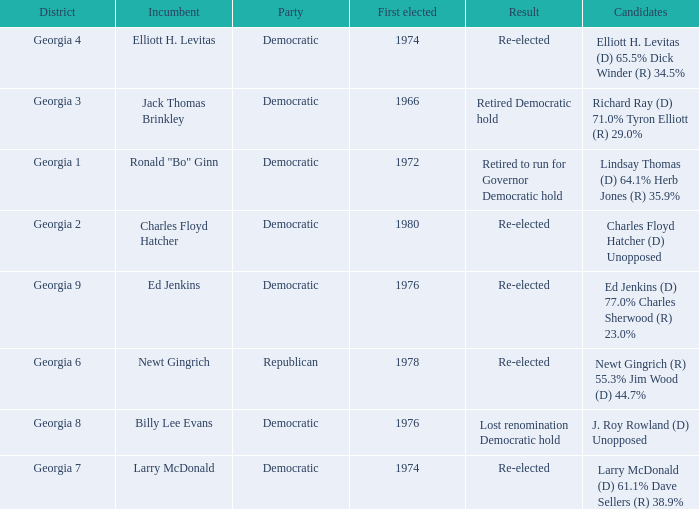Name the districk for larry mcdonald Georgia 7. Could you help me parse every detail presented in this table? {'header': ['District', 'Incumbent', 'Party', 'First elected', 'Result', 'Candidates'], 'rows': [['Georgia 4', 'Elliott H. Levitas', 'Democratic', '1974', 'Re-elected', 'Elliott H. Levitas (D) 65.5% Dick Winder (R) 34.5%'], ['Georgia 3', 'Jack Thomas Brinkley', 'Democratic', '1966', 'Retired Democratic hold', 'Richard Ray (D) 71.0% Tyron Elliott (R) 29.0%'], ['Georgia 1', 'Ronald "Bo" Ginn', 'Democratic', '1972', 'Retired to run for Governor Democratic hold', 'Lindsay Thomas (D) 64.1% Herb Jones (R) 35.9%'], ['Georgia 2', 'Charles Floyd Hatcher', 'Democratic', '1980', 'Re-elected', 'Charles Floyd Hatcher (D) Unopposed'], ['Georgia 9', 'Ed Jenkins', 'Democratic', '1976', 'Re-elected', 'Ed Jenkins (D) 77.0% Charles Sherwood (R) 23.0%'], ['Georgia 6', 'Newt Gingrich', 'Republican', '1978', 'Re-elected', 'Newt Gingrich (R) 55.3% Jim Wood (D) 44.7%'], ['Georgia 8', 'Billy Lee Evans', 'Democratic', '1976', 'Lost renomination Democratic hold', 'J. Roy Rowland (D) Unopposed'], ['Georgia 7', 'Larry McDonald', 'Democratic', '1974', 'Re-elected', 'Larry McDonald (D) 61.1% Dave Sellers (R) 38.9%']]} 